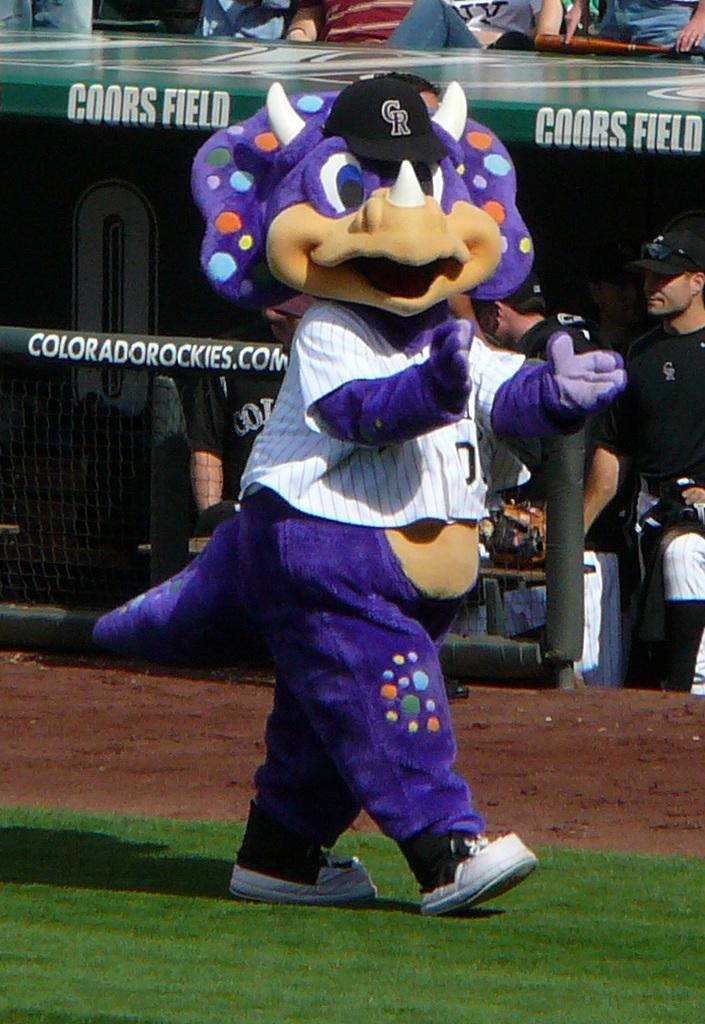Provide a one-sentence caption for the provided image. A baseball mascot in a stegasaurus costume walks past the Colorado Rockies dugout. 